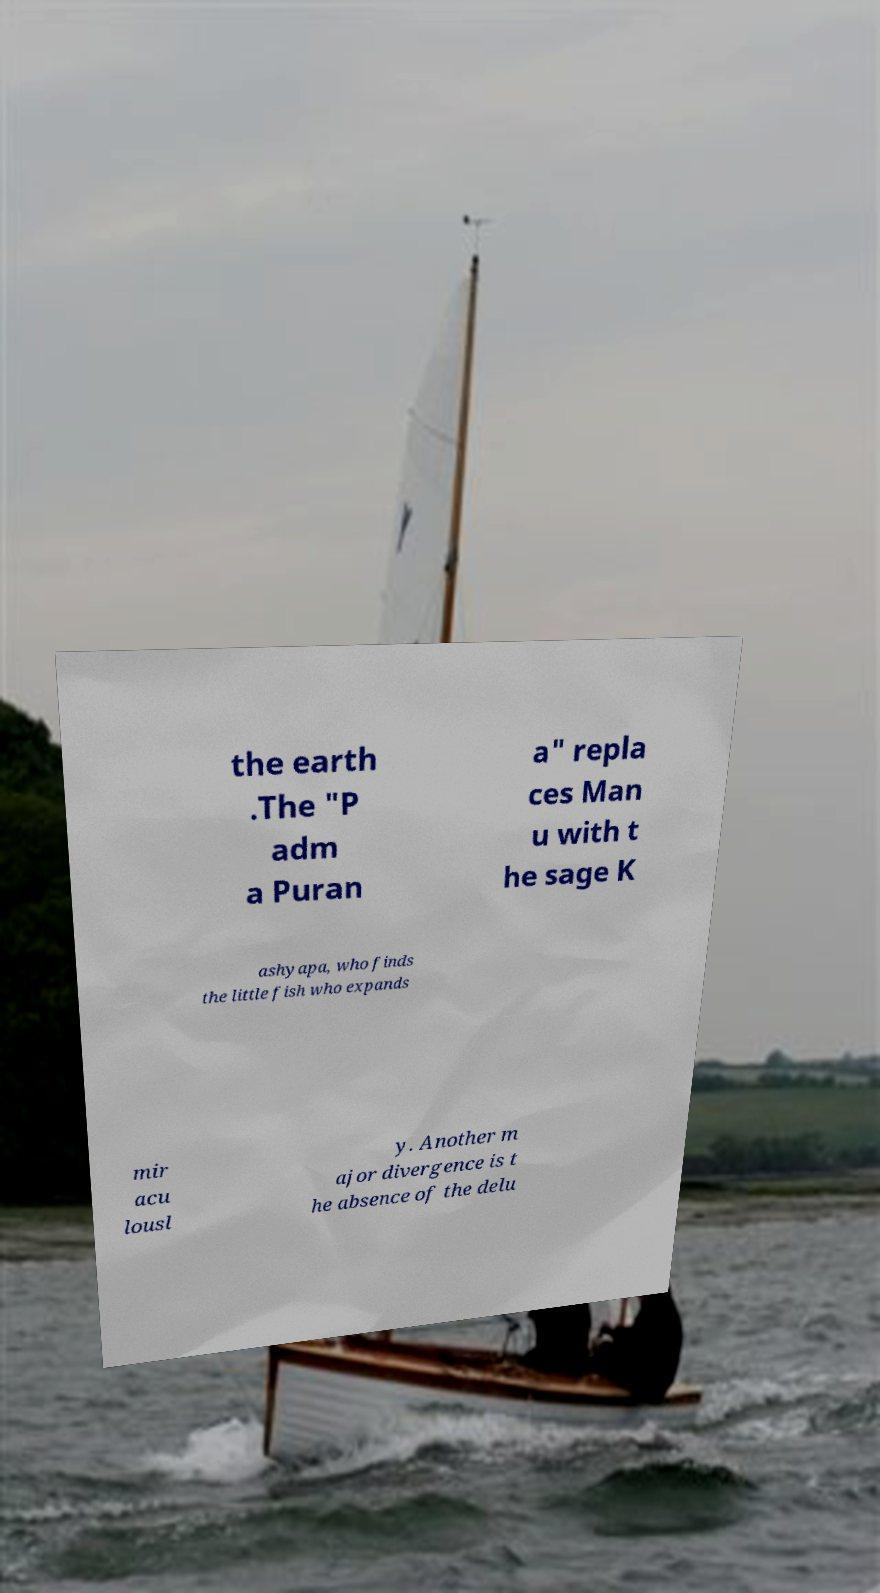Could you extract and type out the text from this image? the earth .The "P adm a Puran a" repla ces Man u with t he sage K ashyapa, who finds the little fish who expands mir acu lousl y. Another m ajor divergence is t he absence of the delu 